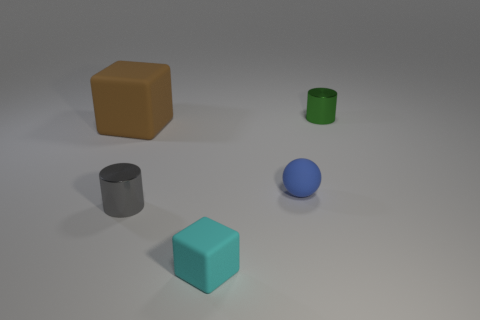Add 2 large cyan matte cylinders. How many objects exist? 7 Subtract all cylinders. How many objects are left? 3 Subtract all small green metal cylinders. Subtract all big things. How many objects are left? 3 Add 4 gray metal things. How many gray metal things are left? 5 Add 5 large metal balls. How many large metal balls exist? 5 Subtract 0 purple blocks. How many objects are left? 5 